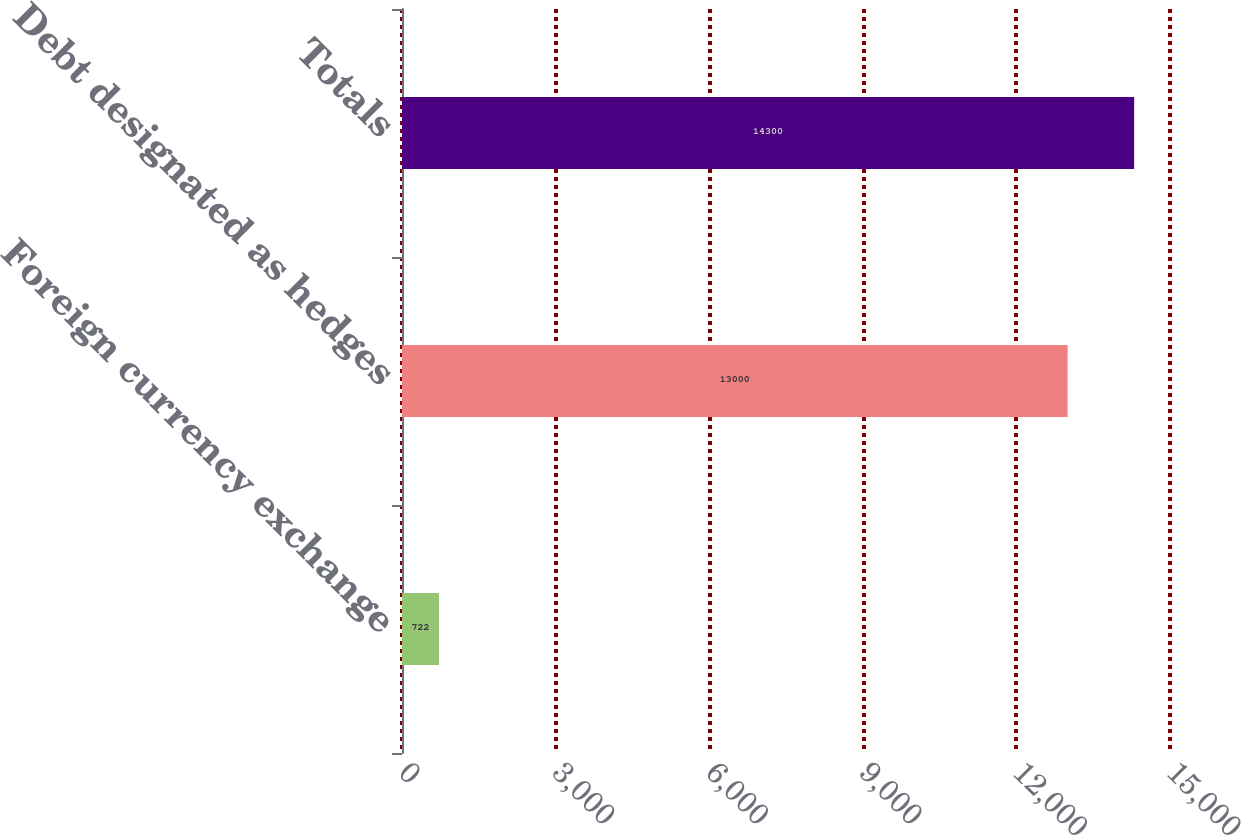Convert chart. <chart><loc_0><loc_0><loc_500><loc_500><bar_chart><fcel>Foreign currency exchange<fcel>Debt designated as hedges<fcel>Totals<nl><fcel>722<fcel>13000<fcel>14300<nl></chart> 